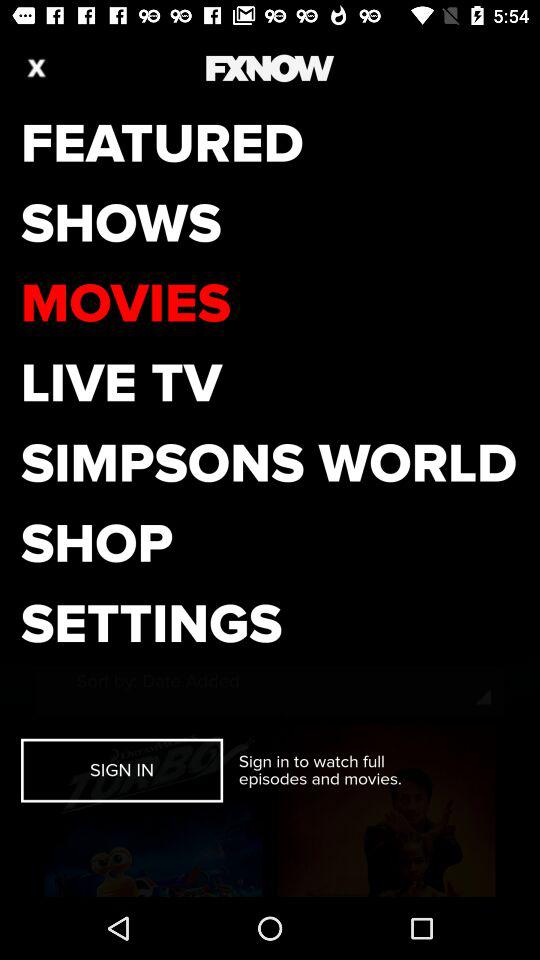What is the application name? The application name is "FXNOW". 